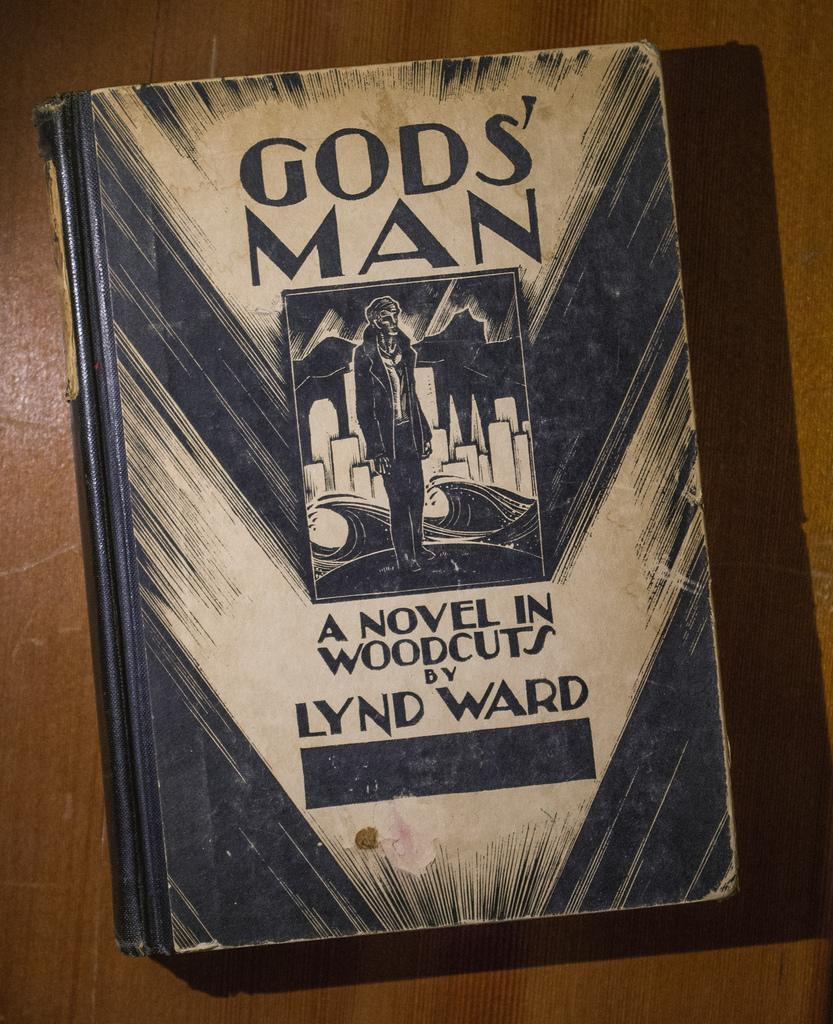<image>
Describe the image concisely. The Lyn Ward book Gods' Man features woodcut art. 